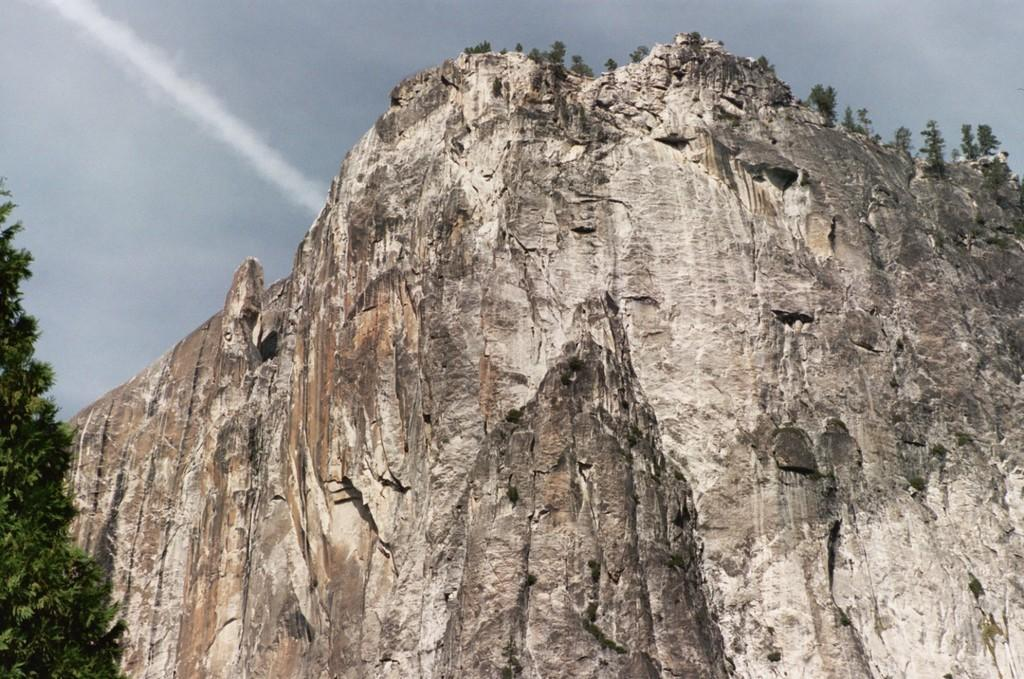What type of landscape feature is visible in the image? There is a hill in the image. Where are trees located in the image? Trees are present on the left side and top of the image. What can be seen in the background of the image? The sky is visible in the background of the image. What type of religious attraction can be seen at the top of the hill in the image? There is no religious attraction present in the image; it only features a hill, trees, and the sky. 